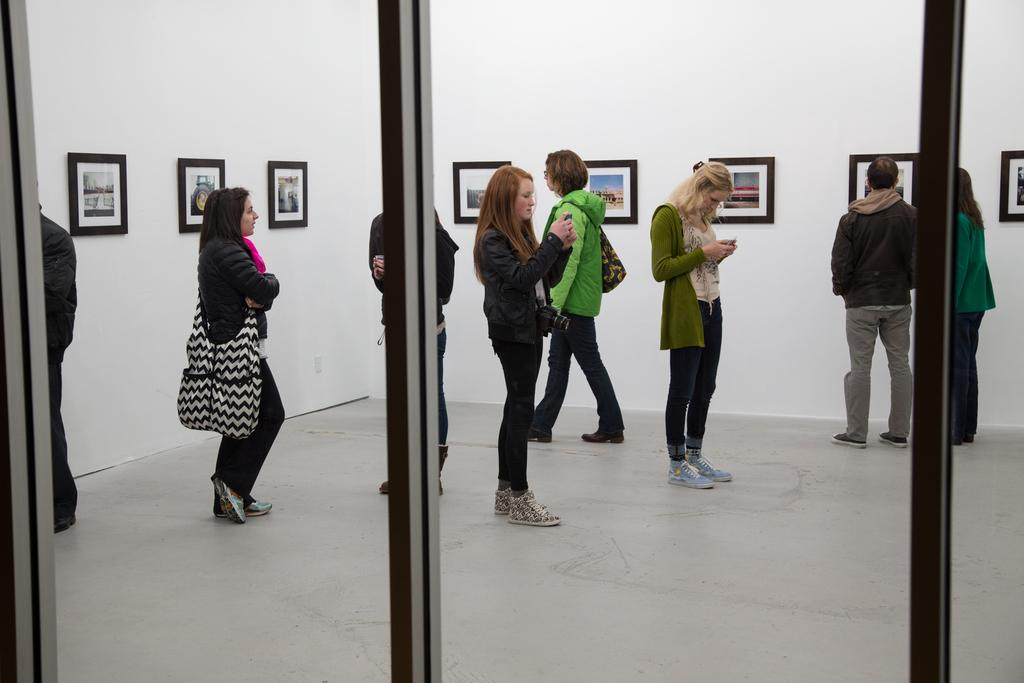What is the main subject of the image? The main subject of the image is a group of people. What are some of the people in the group doing? Some people in the group are holding mobiles. What can be seen in the background of the image? There are frames on the wall in the background of the image. What type of amusement can be seen in the hall or room in the image? There is no mention of a hall or room in the image, nor is there any indication of amusement. 